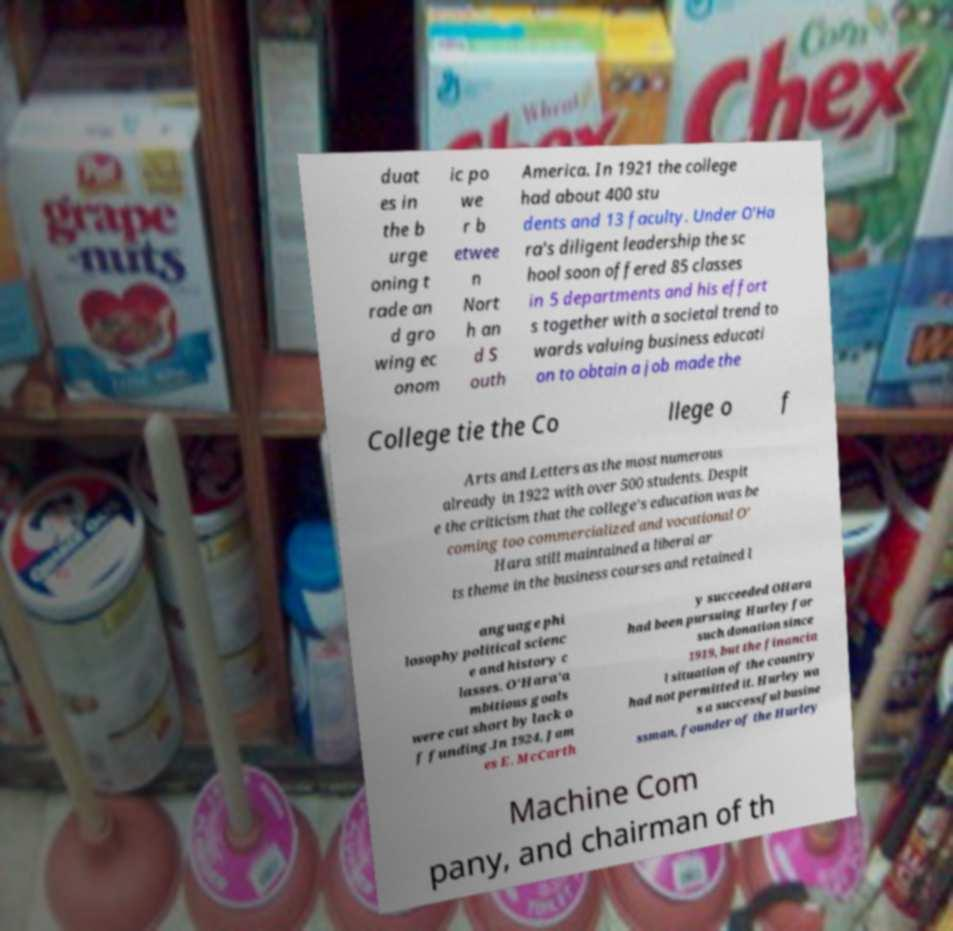Can you accurately transcribe the text from the provided image for me? duat es in the b urge oning t rade an d gro wing ec onom ic po we r b etwee n Nort h an d S outh America. In 1921 the college had about 400 stu dents and 13 faculty. Under O'Ha ra's diligent leadership the sc hool soon offered 85 classes in 5 departments and his effort s together with a societal trend to wards valuing business educati on to obtain a job made the College tie the Co llege o f Arts and Letters as the most numerous already in 1922 with over 500 students. Despit e the criticism that the college's education was be coming too commercialized and vocational O' Hara still maintained a liberal ar ts theme in the business courses and retained l anguage phi losophy political scienc e and history c lasses. O'Hara'a mbitious goals were cut short by lack o f funding.In 1924, Jam es E. McCarth y succeeded OHara had been pursuing Hurley for such donation since 1919, but the financia l situation of the country had not permitted it. Hurley wa s a successful busine ssman, founder of the Hurley Machine Com pany, and chairman of th 